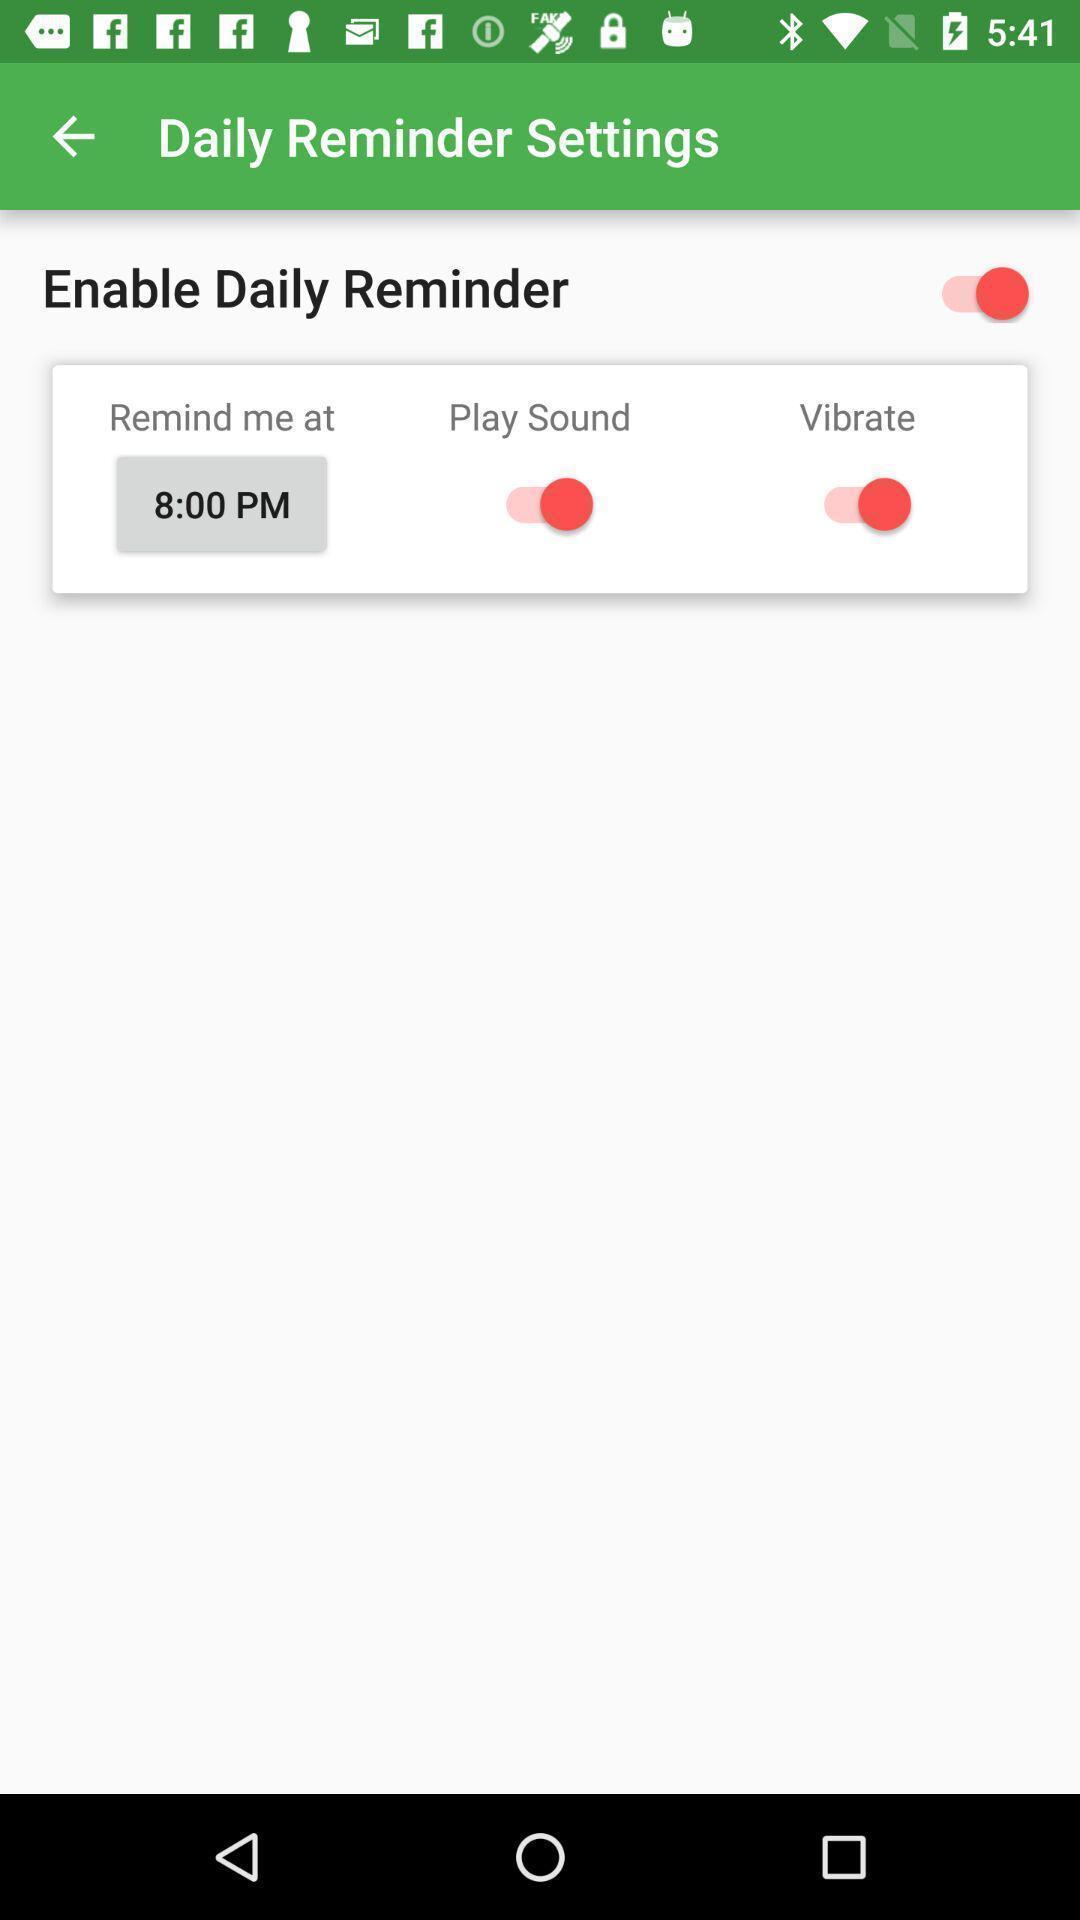Describe the key features of this screenshot. Setting page for the reminders. 